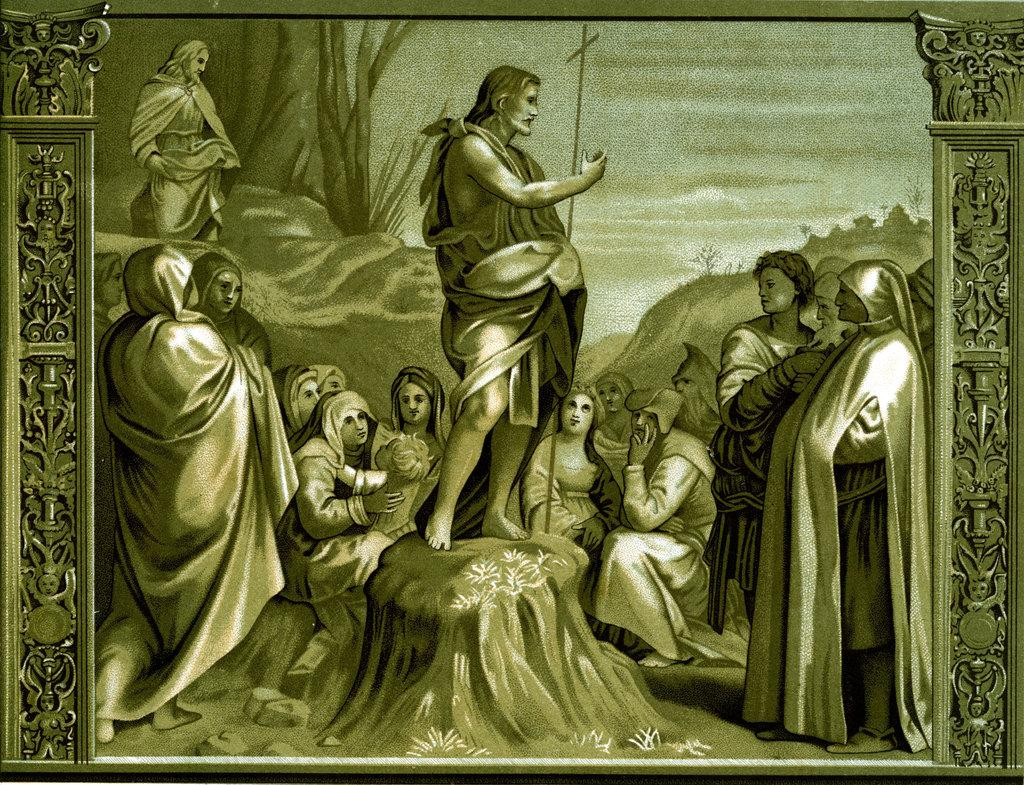What is featured on the poster in the image? There is a poster in the image that contains a painting. What can be seen in the painting? The painting depicts a few people, trees, and grass. What is the ground like in the painting? The ground is visible in the painting. What type of sign can be seen in the painting? There is no sign present in the painting; it only depicts people, trees, grass, and the ground. 